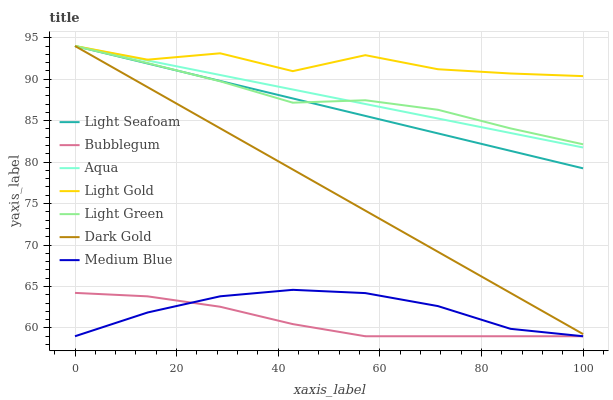Does Bubblegum have the minimum area under the curve?
Answer yes or no. Yes. Does Light Gold have the maximum area under the curve?
Answer yes or no. Yes. Does Medium Blue have the minimum area under the curve?
Answer yes or no. No. Does Medium Blue have the maximum area under the curve?
Answer yes or no. No. Is Dark Gold the smoothest?
Answer yes or no. Yes. Is Light Gold the roughest?
Answer yes or no. Yes. Is Medium Blue the smoothest?
Answer yes or no. No. Is Medium Blue the roughest?
Answer yes or no. No. Does Medium Blue have the lowest value?
Answer yes or no. Yes. Does Aqua have the lowest value?
Answer yes or no. No. Does Light Gold have the highest value?
Answer yes or no. Yes. Does Medium Blue have the highest value?
Answer yes or no. No. Is Medium Blue less than Light Green?
Answer yes or no. Yes. Is Light Gold greater than Medium Blue?
Answer yes or no. Yes. Does Dark Gold intersect Aqua?
Answer yes or no. Yes. Is Dark Gold less than Aqua?
Answer yes or no. No. Is Dark Gold greater than Aqua?
Answer yes or no. No. Does Medium Blue intersect Light Green?
Answer yes or no. No. 